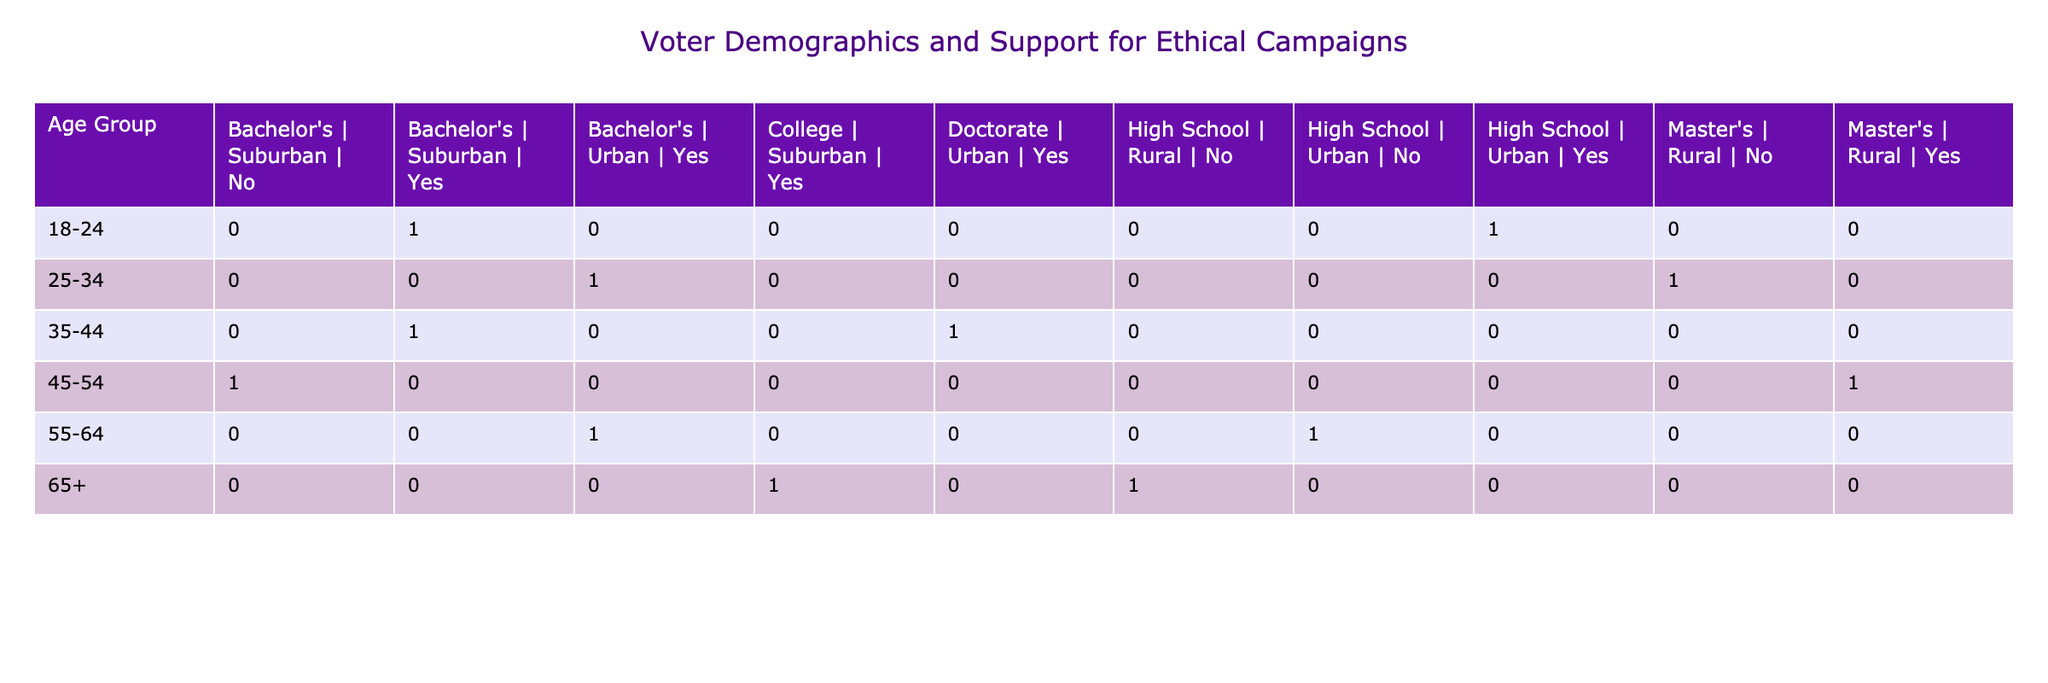What age group has the highest support for ethical campaigns? The age group with the highest support can be identified by reviewing all the "Yes" responses in the Support for Ethical Campaigns column. The 35-44 age group has three instances of support, which is the highest among all age groups.
Answer: 35-44 How many voters from the Bachelor's education level support ethical campaigns? We can find this by filtering the rows where the Voter Education Level is Bachelor's and counting the "Yes" responses in the Support for Ethical Campaigns column. There are four such instances across age groups and regions combined.
Answer: 4 Is there any age group with both high school education residing in a rural region that supports ethical campaigns? To determine this, check the rows for the age group having a high school education and being in a rural region, then look for a "Yes" in their Support for Ethical Campaigns. There is no such case found; therefore, the answer is no.
Answer: No What is the total number of voters who support ethical campaigns and have a Master's degree? Count all instances in the table where voters have a Master's degree and a "Yes" for Support for Ethical Campaigns. Here, there are two cases: one from the 45-54 age group and one from the 25-34 age group. Summing these gives us a total of 2 voters.
Answer: 2 How many voters aged 55-64 do not support ethical campaigns? We look up the rows for the age group 55-64, which shows two voters: one voting "No" with high school education and one voting "Yes" with Bachelor's education. Since there’s only one "No," the total who do not support ethical campaigns is 1.
Answer: 1 In the Suburban region, how does the support for ethical campaigns compare between Bachelor’s and College education? First, filter for voters from the Suburban region with Bachelor's and College education. For Bachelor's, there is one "No" (45-54 age group) and two "Yes" (18-24 and 35-44 age groups), totaling 2 supporting. For College education, there is one "Yes" from the 65+ age group. Therefore, Bachelor's has a greater support of 2 compared to College's 1.
Answer: Bachelor's has greater support Which voter demographic had the least support for ethical campaigns and how much? To find this out, examine all age groups and education levels for the lowest "Yes" responses documented. The demographic with the least support consists of voters aged 65+ with a high school education residing in a rural area, which reflects a total support of 0.
Answer: Voters aged 65+ with high school education in rural area (0 support) What is the difference in support for ethical campaigns between urban and rural regions? We need to aggregate the count of "Yes" responses from both regions. In the urban area, there are six "Yes," and in the rural area, there are two. The difference is therefore 6 (urban) - 2 (rural) = 4.
Answer: 4 